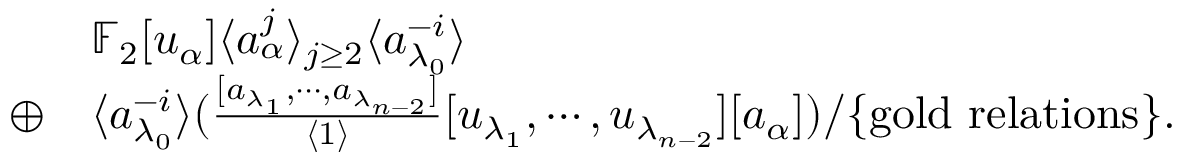Convert formula to latex. <formula><loc_0><loc_0><loc_500><loc_500>\begin{array} { r l } & { \mathbb { F } _ { 2 } [ u _ { \alpha } ] \langle a _ { \alpha } ^ { j } \rangle _ { j \geq 2 } \langle a _ { \lambda _ { 0 } } ^ { - i } \rangle } \\ { \oplus } & { \langle a _ { \lambda _ { 0 } } ^ { - i } \rangle ( \frac { [ a _ { \lambda _ { 1 } } , \cdots , a _ { \lambda _ { n - 2 } } ] } { \langle 1 \rangle } [ u _ { \lambda _ { 1 } } , \cdots , u _ { \lambda _ { n - 2 } } ] [ a _ { \alpha } ] ) / \{ g o l d r e l a t i o n s \} . } \end{array}</formula> 